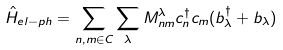<formula> <loc_0><loc_0><loc_500><loc_500>\hat { H } _ { e l - p h } = \sum _ { n , m \in C } \sum _ { \lambda } M ^ { \lambda } _ { n m } c ^ { \dagger } _ { n } c _ { m } ( b ^ { \dagger } _ { \lambda } + b _ { \lambda } )</formula> 